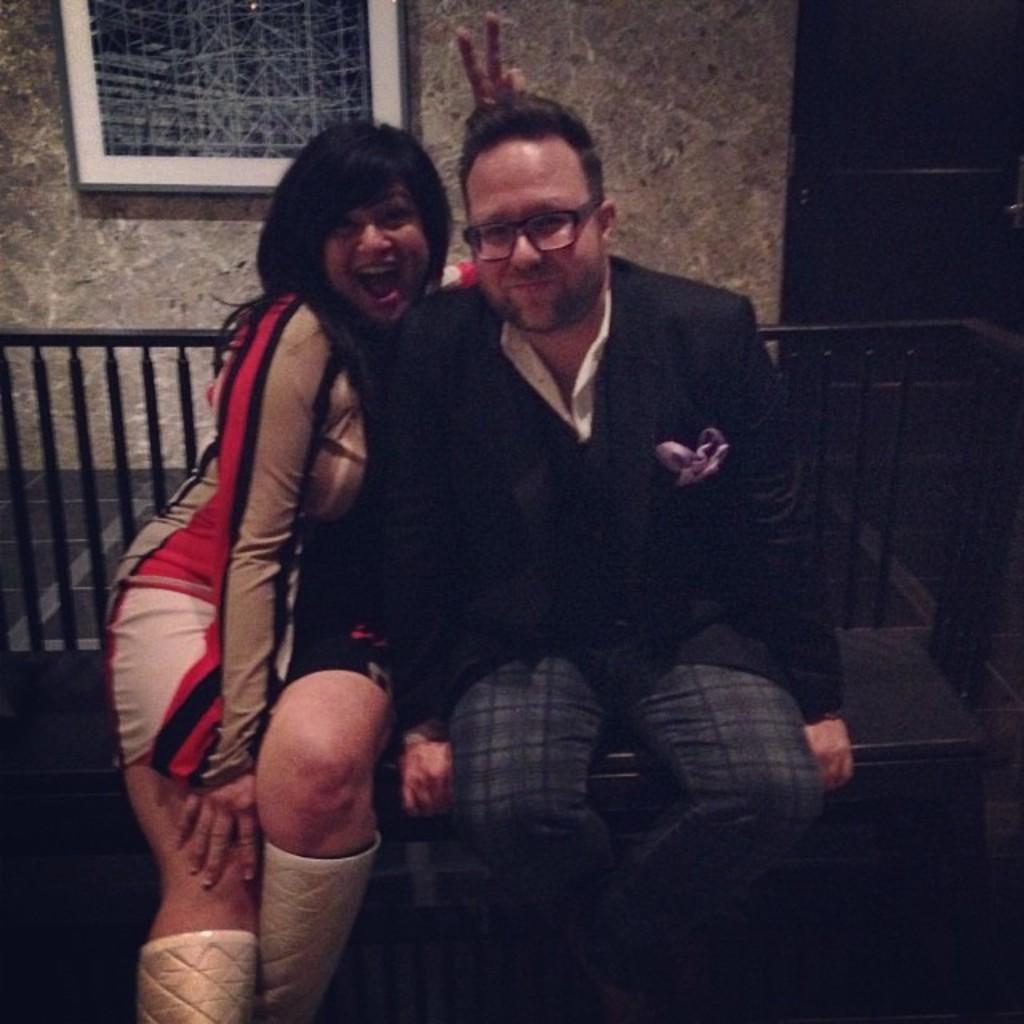In one or two sentences, can you explain what this image depicts? In this image we can see two persons sitting on the bench, there is a railing, there is a photo frame on the wall, also we can see a door. 